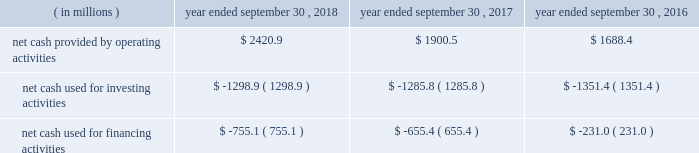Compared to earlier levels .
The pre-tax non-cash impairments of certain mineral rights and real estate discussed above under the caption fffdland and development impairments fffd are not included in segment income .
Liquidity and capital resources on january 29 , 2018 , we announced that a definitive agreement had been signed for us to acquire all of the outstanding shares of kapstone for $ 35.00 per share and the assumption of approximately $ 1.36 billion in net debt , for a total enterprise value of approximately $ 4.9 billion .
In contemplation of the transaction , on march 6 , 2018 , we issued $ 600.0 million aggregate principal amount of 3.75% ( 3.75 % ) senior notes due 2025 and $ 600.0 million aggregate principal amount of 4.0% ( 4.0 % ) senior notes due 2028 in an unregistered offering pursuant to rule 144a and regulation s under the securities act of 1933 , as amended ( the fffdsecurities act fffd ) .
In addition , on march 7 , 2018 , we entered into the delayed draw credit facilities ( as hereinafter defined ) that provide for $ 3.8 billion of senior unsecured term loans .
On november 2 , 2018 , in connection with the closing of the kapstone acquisition , we drew upon the facility in full .
The proceeds of the delayed draw credit facilities ( as hereinafter defined ) and other sources of cash were used to pay the consideration for the kapstone acquisition , to repay certain existing indebtedness of kapstone and to pay fees and expenses incurred in connection with the kapstone acquisition .
We fund our working capital requirements , capital expenditures , mergers , acquisitions and investments , restructuring activities , dividends and stock repurchases from net cash provided by operating activities , borrowings under our credit facilities , proceeds from our new a/r sales agreement ( as hereinafter defined ) , proceeds from the sale of property , plant and equipment removed from service and proceeds received in connection with the issuance of debt and equity securities .
See fffdnote 13 .
Debt fffdtt of the notes to consolidated financial statements for additional information .
Funding for our domestic operations in the foreseeable future is expected to come from sources of liquidity within our domestic operations , including cash and cash equivalents , and available borrowings under our credit facilities .
As such , our foreign cash and cash equivalents are not expected to be a key source of liquidity to our domestic operations .
At september 30 , 2018 , excluding the delayed draw credit facilities , we had approximately $ 3.2 billion of availability under our committed credit facilities , primarily under our revolving credit facility , the majority of which matures on july 1 , 2022 .
This liquidity may be used to provide for ongoing working capital needs and for other general corporate purposes , including acquisitions , dividends and stock repurchases .
Certain restrictive covenants govern our maximum availability under the credit facilities .
We test and report our compliance with these covenants as required and we were in compliance with all of these covenants at september 30 , 2018 .
At september 30 , 2018 , we had $ 104.9 million of outstanding letters of credit not drawn cash and cash equivalents were $ 636.8 million at september 30 , 2018 and $ 298.1 million at september 30 , 2017 .
We used a significant portion of the cash and cash equivalents on hand at september 30 , 2018 in connection with the closing of the kapstone acquisition .
Approximately 20% ( 20 % ) of the cash and cash equivalents at september 30 , 2018 were held outside of the u.s .
At september 30 , 2018 , total debt was $ 6415.2 million , $ 740.7 million of which was current .
At september 30 , 2017 , total debt was $ 6554.8 million , $ 608.7 million of which was current .
Cash flow activityy .
Net cash provided by operating activities during fiscal 2018 increased $ 520.4 million from fiscal 2017 primarily due to higher cash earnings and lower cash taxes due to the impact of the tax act .
Net cash provided by operating activities during fiscal 2017 increased $ 212.1 million from fiscal 2016 primarily due to a $ 111.6 million net increase in cash flow from working capital changes plus higher after-tax cash proceeds from our land and development segment fffds accelerated monetization .
The changes in working capital in fiscal 2018 , 2017 and 2016 included a .
What percent of the increase in net cash from operations between 2016 and 2017 was due to working capital changes? 
Computations: (111.6 / 212.1)
Answer: 0.52617. Compared to earlier levels .
The pre-tax non-cash impairments of certain mineral rights and real estate discussed above under the caption fffdland and development impairments fffd are not included in segment income .
Liquidity and capital resources on january 29 , 2018 , we announced that a definitive agreement had been signed for us to acquire all of the outstanding shares of kapstone for $ 35.00 per share and the assumption of approximately $ 1.36 billion in net debt , for a total enterprise value of approximately $ 4.9 billion .
In contemplation of the transaction , on march 6 , 2018 , we issued $ 600.0 million aggregate principal amount of 3.75% ( 3.75 % ) senior notes due 2025 and $ 600.0 million aggregate principal amount of 4.0% ( 4.0 % ) senior notes due 2028 in an unregistered offering pursuant to rule 144a and regulation s under the securities act of 1933 , as amended ( the fffdsecurities act fffd ) .
In addition , on march 7 , 2018 , we entered into the delayed draw credit facilities ( as hereinafter defined ) that provide for $ 3.8 billion of senior unsecured term loans .
On november 2 , 2018 , in connection with the closing of the kapstone acquisition , we drew upon the facility in full .
The proceeds of the delayed draw credit facilities ( as hereinafter defined ) and other sources of cash were used to pay the consideration for the kapstone acquisition , to repay certain existing indebtedness of kapstone and to pay fees and expenses incurred in connection with the kapstone acquisition .
We fund our working capital requirements , capital expenditures , mergers , acquisitions and investments , restructuring activities , dividends and stock repurchases from net cash provided by operating activities , borrowings under our credit facilities , proceeds from our new a/r sales agreement ( as hereinafter defined ) , proceeds from the sale of property , plant and equipment removed from service and proceeds received in connection with the issuance of debt and equity securities .
See fffdnote 13 .
Debt fffdtt of the notes to consolidated financial statements for additional information .
Funding for our domestic operations in the foreseeable future is expected to come from sources of liquidity within our domestic operations , including cash and cash equivalents , and available borrowings under our credit facilities .
As such , our foreign cash and cash equivalents are not expected to be a key source of liquidity to our domestic operations .
At september 30 , 2018 , excluding the delayed draw credit facilities , we had approximately $ 3.2 billion of availability under our committed credit facilities , primarily under our revolving credit facility , the majority of which matures on july 1 , 2022 .
This liquidity may be used to provide for ongoing working capital needs and for other general corporate purposes , including acquisitions , dividends and stock repurchases .
Certain restrictive covenants govern our maximum availability under the credit facilities .
We test and report our compliance with these covenants as required and we were in compliance with all of these covenants at september 30 , 2018 .
At september 30 , 2018 , we had $ 104.9 million of outstanding letters of credit not drawn cash and cash equivalents were $ 636.8 million at september 30 , 2018 and $ 298.1 million at september 30 , 2017 .
We used a significant portion of the cash and cash equivalents on hand at september 30 , 2018 in connection with the closing of the kapstone acquisition .
Approximately 20% ( 20 % ) of the cash and cash equivalents at september 30 , 2018 were held outside of the u.s .
At september 30 , 2018 , total debt was $ 6415.2 million , $ 740.7 million of which was current .
At september 30 , 2017 , total debt was $ 6554.8 million , $ 608.7 million of which was current .
Cash flow activityy .
Net cash provided by operating activities during fiscal 2018 increased $ 520.4 million from fiscal 2017 primarily due to higher cash earnings and lower cash taxes due to the impact of the tax act .
Net cash provided by operating activities during fiscal 2017 increased $ 212.1 million from fiscal 2016 primarily due to a $ 111.6 million net increase in cash flow from working capital changes plus higher after-tax cash proceeds from our land and development segment fffds accelerated monetization .
The changes in working capital in fiscal 2018 , 2017 and 2016 included a .
As of september 30 , 2018 , what was the percent of the total debt that was current .? 
Computations: (740.7 / 6415.2)
Answer: 0.11546. 